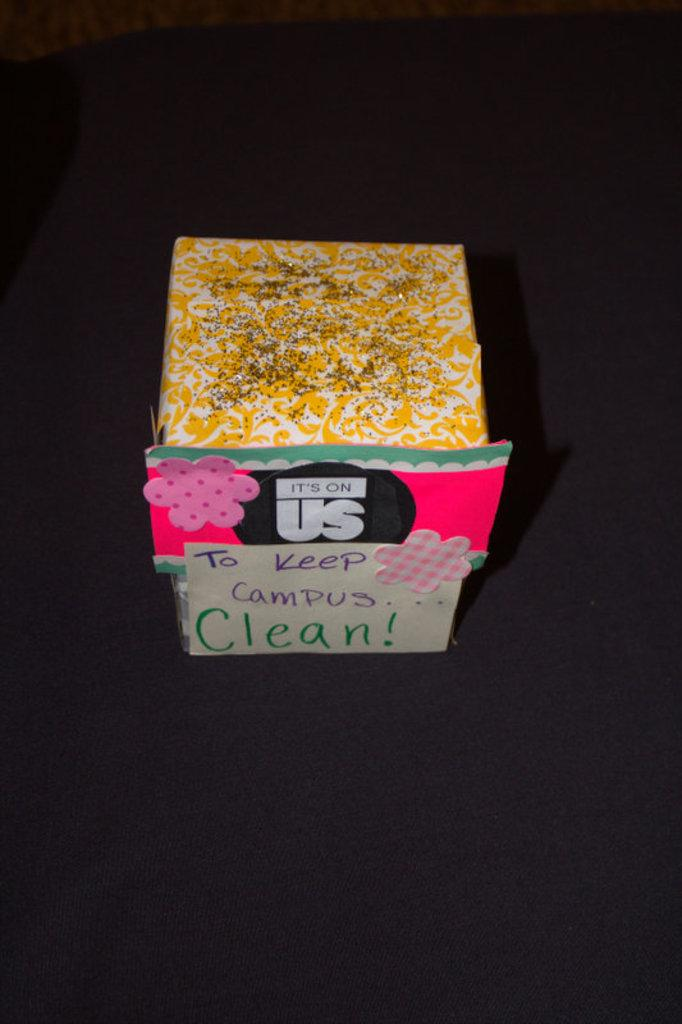<image>
Create a compact narrative representing the image presented. Small colorful box hand decorated stating that it is on us to keep the campus clean. 